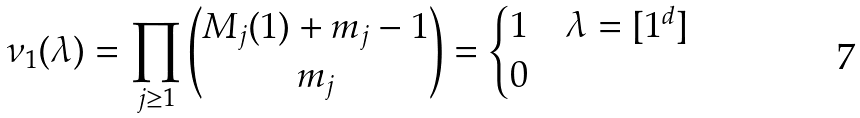Convert formula to latex. <formula><loc_0><loc_0><loc_500><loc_500>\nu _ { 1 } ( \lambda ) = \prod _ { j \geq 1 } \binom { M _ { j } ( 1 ) + m _ { j } - 1 } { m _ { j } } = \begin{cases} 1 & \lambda = [ 1 ^ { d } ] \\ 0 & \end{cases}</formula> 